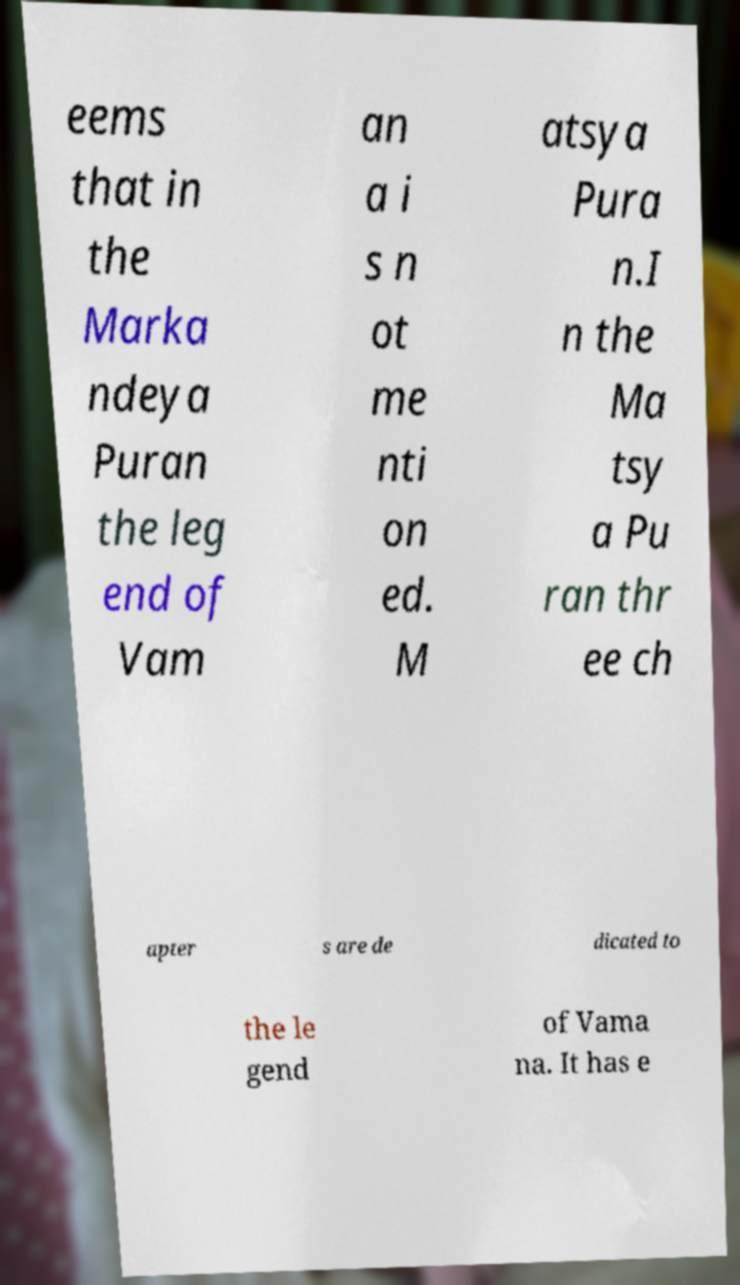Please read and relay the text visible in this image. What does it say? eems that in the Marka ndeya Puran the leg end of Vam an a i s n ot me nti on ed. M atsya Pura n.I n the Ma tsy a Pu ran thr ee ch apter s are de dicated to the le gend of Vama na. It has e 